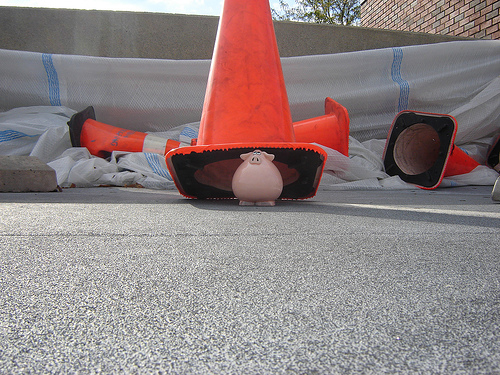<image>
Is the pig under the traffic cone? Yes. The pig is positioned underneath the traffic cone, with the traffic cone above it in the vertical space. 